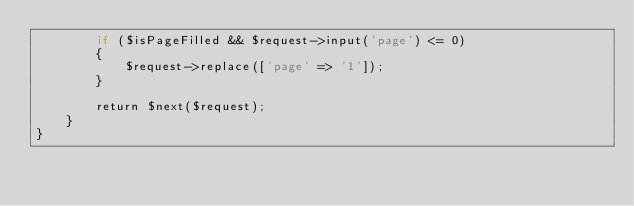<code> <loc_0><loc_0><loc_500><loc_500><_PHP_>        if ($isPageFilled && $request->input('page') <= 0)
        {
            $request->replace(['page' => '1']);
        }

        return $next($request);
    }
}
</code> 